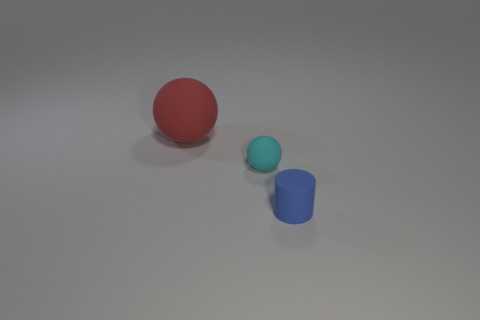Are the objects arranged in a specific pattern or order? The arrangement of the objects in the image does not seem to follow any recognizable pattern or specific order. They are spaced apart in a way that might suggest a casual layout, with no apparent intent to create symmetry or alignment.  Could this arrangement have a symbolic meaning? It's possible to interpret the arrangement from an artistic perspective and imbue it with symbolic meaning. However, without further context, the image seems to present a straightforward display of three separate objects with distinct shapes and colors, likely for the purpose of visual comparison or examination. 